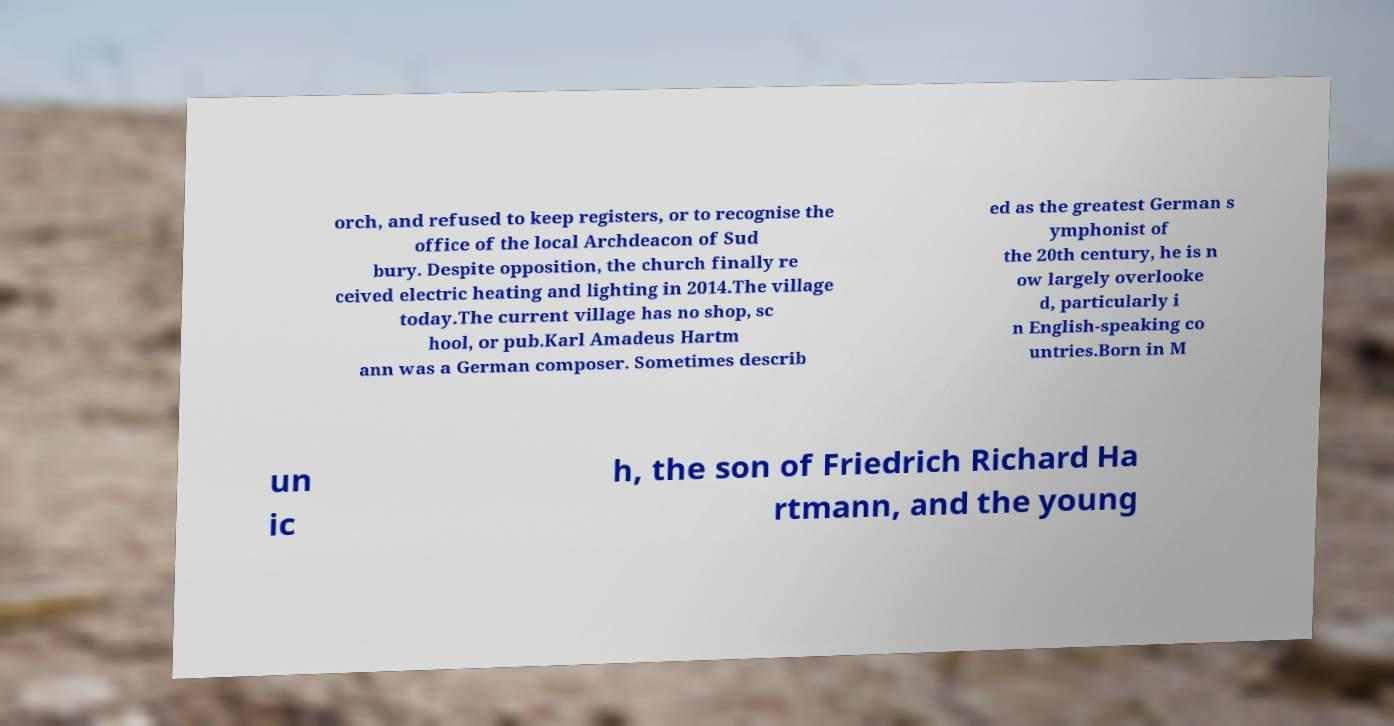I need the written content from this picture converted into text. Can you do that? orch, and refused to keep registers, or to recognise the office of the local Archdeacon of Sud bury. Despite opposition, the church finally re ceived electric heating and lighting in 2014.The village today.The current village has no shop, sc hool, or pub.Karl Amadeus Hartm ann was a German composer. Sometimes describ ed as the greatest German s ymphonist of the 20th century, he is n ow largely overlooke d, particularly i n English-speaking co untries.Born in M un ic h, the son of Friedrich Richard Ha rtmann, and the young 